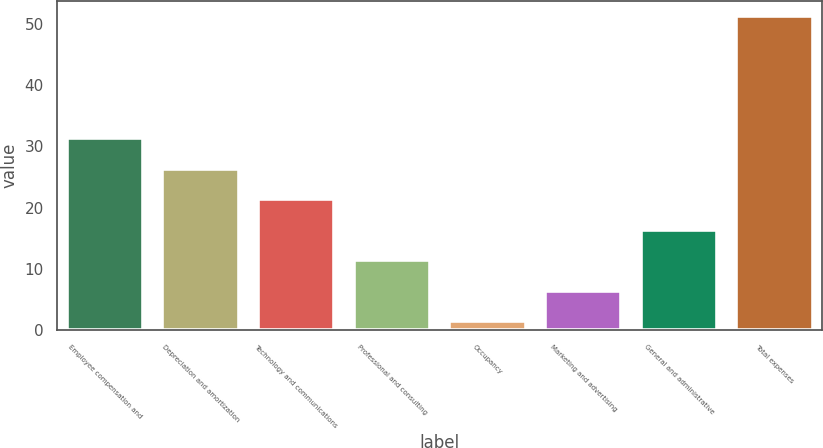Convert chart. <chart><loc_0><loc_0><loc_500><loc_500><bar_chart><fcel>Employee compensation and<fcel>Depreciation and amortization<fcel>Technology and communications<fcel>Professional and consulting<fcel>Occupancy<fcel>Marketing and advertising<fcel>General and administrative<fcel>Total expenses<nl><fcel>31.32<fcel>26.35<fcel>21.38<fcel>11.44<fcel>1.5<fcel>6.47<fcel>16.41<fcel>51.2<nl></chart> 